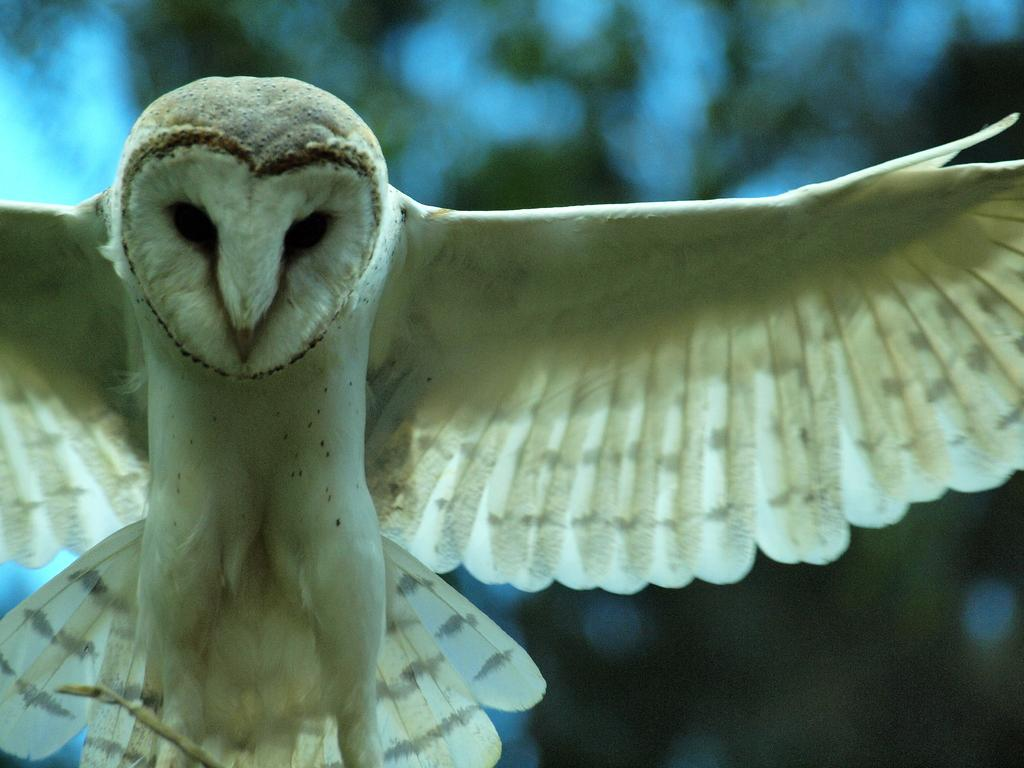What animal is in the image? There is an owl in the image. Where is the owl located in the image? The owl is on the left side of the image. Can you describe the background of the image? The background area of the image is blurred. What type of account does the owl have in the image? There is no indication of an account in the image, as it features an owl and a blurred background. 